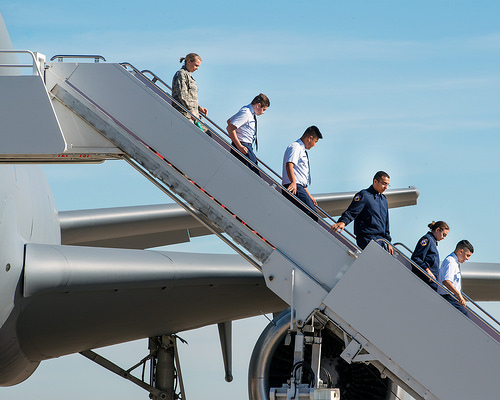<image>
Can you confirm if the airplane is under the stairs? No. The airplane is not positioned under the stairs. The vertical relationship between these objects is different. Is there a man to the right of the man? No. The man is not to the right of the man. The horizontal positioning shows a different relationship. 